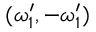Convert formula to latex. <formula><loc_0><loc_0><loc_500><loc_500>( \omega _ { 1 } ^ { \prime } , - \omega _ { 1 } ^ { \prime } )</formula> 